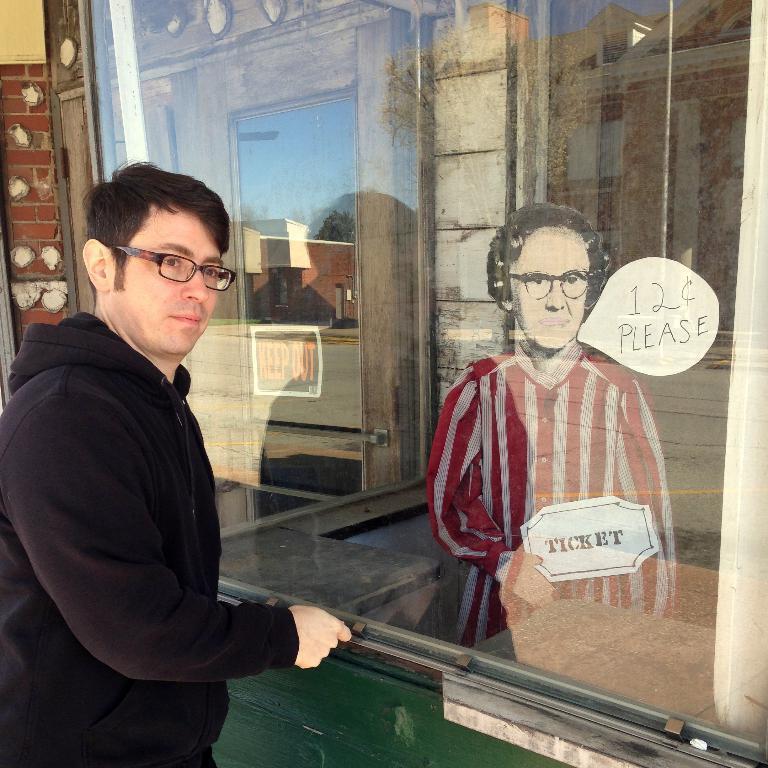How would you summarize this image in a sentence or two? In this image there is a person, he is standing in front of a glass beside the glass there is a doll. 